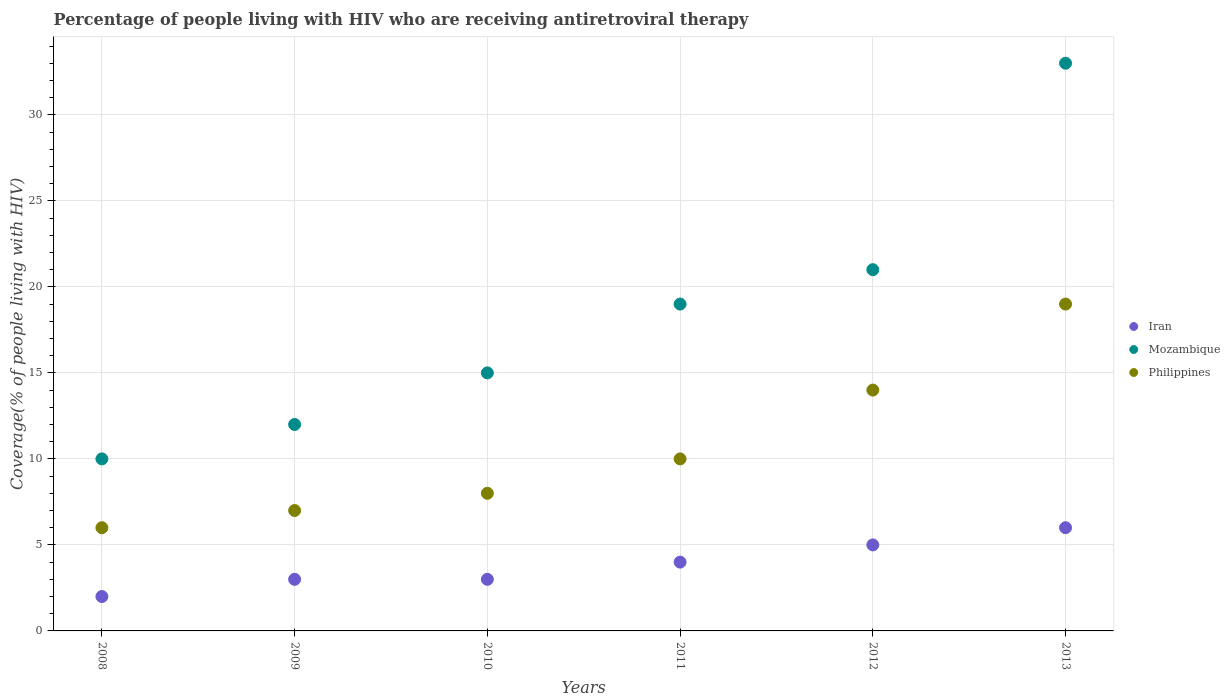Is the number of dotlines equal to the number of legend labels?
Your answer should be compact. Yes. What is the percentage of the HIV infected people who are receiving antiretroviral therapy in Mozambique in 2012?
Give a very brief answer. 21. Across all years, what is the maximum percentage of the HIV infected people who are receiving antiretroviral therapy in Iran?
Your answer should be very brief. 6. What is the total percentage of the HIV infected people who are receiving antiretroviral therapy in Philippines in the graph?
Give a very brief answer. 64. What is the difference between the percentage of the HIV infected people who are receiving antiretroviral therapy in Iran in 2010 and that in 2011?
Give a very brief answer. -1. What is the difference between the percentage of the HIV infected people who are receiving antiretroviral therapy in Mozambique in 2011 and the percentage of the HIV infected people who are receiving antiretroviral therapy in Iran in 2013?
Your response must be concise. 13. What is the average percentage of the HIV infected people who are receiving antiretroviral therapy in Mozambique per year?
Provide a short and direct response. 18.33. In the year 2008, what is the difference between the percentage of the HIV infected people who are receiving antiretroviral therapy in Iran and percentage of the HIV infected people who are receiving antiretroviral therapy in Mozambique?
Your response must be concise. -8. What is the ratio of the percentage of the HIV infected people who are receiving antiretroviral therapy in Iran in 2009 to that in 2012?
Your answer should be very brief. 0.6. Is the percentage of the HIV infected people who are receiving antiretroviral therapy in Mozambique in 2009 less than that in 2013?
Provide a short and direct response. Yes. Is the difference between the percentage of the HIV infected people who are receiving antiretroviral therapy in Iran in 2009 and 2012 greater than the difference between the percentage of the HIV infected people who are receiving antiretroviral therapy in Mozambique in 2009 and 2012?
Make the answer very short. Yes. What is the difference between the highest and the second highest percentage of the HIV infected people who are receiving antiretroviral therapy in Iran?
Your answer should be compact. 1. What is the difference between the highest and the lowest percentage of the HIV infected people who are receiving antiretroviral therapy in Philippines?
Your answer should be very brief. 13. Is the sum of the percentage of the HIV infected people who are receiving antiretroviral therapy in Iran in 2009 and 2013 greater than the maximum percentage of the HIV infected people who are receiving antiretroviral therapy in Mozambique across all years?
Make the answer very short. No. Is it the case that in every year, the sum of the percentage of the HIV infected people who are receiving antiretroviral therapy in Iran and percentage of the HIV infected people who are receiving antiretroviral therapy in Philippines  is greater than the percentage of the HIV infected people who are receiving antiretroviral therapy in Mozambique?
Your response must be concise. No. Is the percentage of the HIV infected people who are receiving antiretroviral therapy in Iran strictly less than the percentage of the HIV infected people who are receiving antiretroviral therapy in Mozambique over the years?
Offer a terse response. Yes. How many dotlines are there?
Offer a very short reply. 3. How many years are there in the graph?
Provide a short and direct response. 6. What is the difference between two consecutive major ticks on the Y-axis?
Your answer should be compact. 5. What is the title of the graph?
Your answer should be very brief. Percentage of people living with HIV who are receiving antiretroviral therapy. What is the label or title of the Y-axis?
Your answer should be very brief. Coverage(% of people living with HIV). What is the Coverage(% of people living with HIV) of Iran in 2008?
Offer a very short reply. 2. What is the Coverage(% of people living with HIV) in Philippines in 2009?
Give a very brief answer. 7. What is the Coverage(% of people living with HIV) of Iran in 2010?
Your response must be concise. 3. What is the Coverage(% of people living with HIV) of Iran in 2011?
Make the answer very short. 4. What is the Coverage(% of people living with HIV) of Mozambique in 2011?
Provide a succinct answer. 19. What is the Coverage(% of people living with HIV) in Iran in 2013?
Offer a very short reply. 6. What is the Coverage(% of people living with HIV) in Philippines in 2013?
Keep it short and to the point. 19. Across all years, what is the maximum Coverage(% of people living with HIV) in Iran?
Your answer should be very brief. 6. Across all years, what is the minimum Coverage(% of people living with HIV) in Iran?
Your response must be concise. 2. Across all years, what is the minimum Coverage(% of people living with HIV) in Mozambique?
Offer a terse response. 10. Across all years, what is the minimum Coverage(% of people living with HIV) of Philippines?
Your answer should be very brief. 6. What is the total Coverage(% of people living with HIV) in Mozambique in the graph?
Make the answer very short. 110. What is the total Coverage(% of people living with HIV) of Philippines in the graph?
Make the answer very short. 64. What is the difference between the Coverage(% of people living with HIV) in Iran in 2008 and that in 2009?
Give a very brief answer. -1. What is the difference between the Coverage(% of people living with HIV) in Mozambique in 2008 and that in 2009?
Ensure brevity in your answer.  -2. What is the difference between the Coverage(% of people living with HIV) of Philippines in 2008 and that in 2009?
Give a very brief answer. -1. What is the difference between the Coverage(% of people living with HIV) of Iran in 2008 and that in 2011?
Give a very brief answer. -2. What is the difference between the Coverage(% of people living with HIV) of Iran in 2008 and that in 2012?
Provide a succinct answer. -3. What is the difference between the Coverage(% of people living with HIV) of Iran in 2008 and that in 2013?
Offer a terse response. -4. What is the difference between the Coverage(% of people living with HIV) of Philippines in 2008 and that in 2013?
Your response must be concise. -13. What is the difference between the Coverage(% of people living with HIV) in Iran in 2009 and that in 2010?
Your response must be concise. 0. What is the difference between the Coverage(% of people living with HIV) of Philippines in 2009 and that in 2010?
Give a very brief answer. -1. What is the difference between the Coverage(% of people living with HIV) of Iran in 2009 and that in 2011?
Keep it short and to the point. -1. What is the difference between the Coverage(% of people living with HIV) of Philippines in 2009 and that in 2013?
Provide a succinct answer. -12. What is the difference between the Coverage(% of people living with HIV) of Mozambique in 2010 and that in 2011?
Make the answer very short. -4. What is the difference between the Coverage(% of people living with HIV) of Philippines in 2010 and that in 2011?
Your answer should be very brief. -2. What is the difference between the Coverage(% of people living with HIV) in Mozambique in 2010 and that in 2012?
Keep it short and to the point. -6. What is the difference between the Coverage(% of people living with HIV) in Philippines in 2010 and that in 2012?
Provide a short and direct response. -6. What is the difference between the Coverage(% of people living with HIV) of Mozambique in 2011 and that in 2012?
Make the answer very short. -2. What is the difference between the Coverage(% of people living with HIV) in Philippines in 2011 and that in 2012?
Your answer should be very brief. -4. What is the difference between the Coverage(% of people living with HIV) of Philippines in 2011 and that in 2013?
Make the answer very short. -9. What is the difference between the Coverage(% of people living with HIV) in Iran in 2012 and that in 2013?
Give a very brief answer. -1. What is the difference between the Coverage(% of people living with HIV) in Iran in 2008 and the Coverage(% of people living with HIV) in Mozambique in 2009?
Give a very brief answer. -10. What is the difference between the Coverage(% of people living with HIV) in Iran in 2008 and the Coverage(% of people living with HIV) in Philippines in 2009?
Offer a terse response. -5. What is the difference between the Coverage(% of people living with HIV) of Iran in 2008 and the Coverage(% of people living with HIV) of Mozambique in 2010?
Keep it short and to the point. -13. What is the difference between the Coverage(% of people living with HIV) of Iran in 2008 and the Coverage(% of people living with HIV) of Philippines in 2011?
Your answer should be very brief. -8. What is the difference between the Coverage(% of people living with HIV) in Mozambique in 2008 and the Coverage(% of people living with HIV) in Philippines in 2011?
Provide a succinct answer. 0. What is the difference between the Coverage(% of people living with HIV) in Iran in 2008 and the Coverage(% of people living with HIV) in Mozambique in 2013?
Give a very brief answer. -31. What is the difference between the Coverage(% of people living with HIV) of Iran in 2008 and the Coverage(% of people living with HIV) of Philippines in 2013?
Your answer should be compact. -17. What is the difference between the Coverage(% of people living with HIV) in Iran in 2009 and the Coverage(% of people living with HIV) in Philippines in 2010?
Ensure brevity in your answer.  -5. What is the difference between the Coverage(% of people living with HIV) in Mozambique in 2009 and the Coverage(% of people living with HIV) in Philippines in 2010?
Provide a short and direct response. 4. What is the difference between the Coverage(% of people living with HIV) of Mozambique in 2009 and the Coverage(% of people living with HIV) of Philippines in 2011?
Your answer should be very brief. 2. What is the difference between the Coverage(% of people living with HIV) in Iran in 2009 and the Coverage(% of people living with HIV) in Philippines in 2012?
Provide a short and direct response. -11. What is the difference between the Coverage(% of people living with HIV) of Mozambique in 2009 and the Coverage(% of people living with HIV) of Philippines in 2012?
Give a very brief answer. -2. What is the difference between the Coverage(% of people living with HIV) in Iran in 2009 and the Coverage(% of people living with HIV) in Mozambique in 2013?
Offer a very short reply. -30. What is the difference between the Coverage(% of people living with HIV) of Mozambique in 2009 and the Coverage(% of people living with HIV) of Philippines in 2013?
Keep it short and to the point. -7. What is the difference between the Coverage(% of people living with HIV) in Iran in 2010 and the Coverage(% of people living with HIV) in Mozambique in 2011?
Give a very brief answer. -16. What is the difference between the Coverage(% of people living with HIV) of Iran in 2010 and the Coverage(% of people living with HIV) of Mozambique in 2012?
Make the answer very short. -18. What is the difference between the Coverage(% of people living with HIV) in Iran in 2010 and the Coverage(% of people living with HIV) in Philippines in 2012?
Make the answer very short. -11. What is the difference between the Coverage(% of people living with HIV) of Iran in 2010 and the Coverage(% of people living with HIV) of Philippines in 2013?
Make the answer very short. -16. What is the difference between the Coverage(% of people living with HIV) in Iran in 2011 and the Coverage(% of people living with HIV) in Mozambique in 2012?
Offer a terse response. -17. What is the difference between the Coverage(% of people living with HIV) in Iran in 2011 and the Coverage(% of people living with HIV) in Mozambique in 2013?
Give a very brief answer. -29. What is the difference between the Coverage(% of people living with HIV) of Mozambique in 2011 and the Coverage(% of people living with HIV) of Philippines in 2013?
Provide a short and direct response. 0. What is the difference between the Coverage(% of people living with HIV) in Iran in 2012 and the Coverage(% of people living with HIV) in Mozambique in 2013?
Offer a terse response. -28. What is the difference between the Coverage(% of people living with HIV) in Mozambique in 2012 and the Coverage(% of people living with HIV) in Philippines in 2013?
Ensure brevity in your answer.  2. What is the average Coverage(% of people living with HIV) in Iran per year?
Offer a terse response. 3.83. What is the average Coverage(% of people living with HIV) of Mozambique per year?
Offer a terse response. 18.33. What is the average Coverage(% of people living with HIV) of Philippines per year?
Offer a very short reply. 10.67. In the year 2008, what is the difference between the Coverage(% of people living with HIV) of Iran and Coverage(% of people living with HIV) of Philippines?
Offer a very short reply. -4. In the year 2010, what is the difference between the Coverage(% of people living with HIV) in Iran and Coverage(% of people living with HIV) in Philippines?
Offer a very short reply. -5. In the year 2011, what is the difference between the Coverage(% of people living with HIV) of Iran and Coverage(% of people living with HIV) of Mozambique?
Your answer should be compact. -15. In the year 2011, what is the difference between the Coverage(% of people living with HIV) in Mozambique and Coverage(% of people living with HIV) in Philippines?
Your answer should be very brief. 9. In the year 2012, what is the difference between the Coverage(% of people living with HIV) of Iran and Coverage(% of people living with HIV) of Mozambique?
Make the answer very short. -16. In the year 2012, what is the difference between the Coverage(% of people living with HIV) in Iran and Coverage(% of people living with HIV) in Philippines?
Offer a terse response. -9. In the year 2012, what is the difference between the Coverage(% of people living with HIV) in Mozambique and Coverage(% of people living with HIV) in Philippines?
Your answer should be compact. 7. In the year 2013, what is the difference between the Coverage(% of people living with HIV) in Iran and Coverage(% of people living with HIV) in Mozambique?
Keep it short and to the point. -27. What is the ratio of the Coverage(% of people living with HIV) of Iran in 2008 to that in 2009?
Provide a short and direct response. 0.67. What is the ratio of the Coverage(% of people living with HIV) of Mozambique in 2008 to that in 2009?
Ensure brevity in your answer.  0.83. What is the ratio of the Coverage(% of people living with HIV) in Philippines in 2008 to that in 2009?
Provide a short and direct response. 0.86. What is the ratio of the Coverage(% of people living with HIV) of Iran in 2008 to that in 2010?
Your answer should be very brief. 0.67. What is the ratio of the Coverage(% of people living with HIV) in Philippines in 2008 to that in 2010?
Provide a short and direct response. 0.75. What is the ratio of the Coverage(% of people living with HIV) in Iran in 2008 to that in 2011?
Provide a succinct answer. 0.5. What is the ratio of the Coverage(% of people living with HIV) in Mozambique in 2008 to that in 2011?
Keep it short and to the point. 0.53. What is the ratio of the Coverage(% of people living with HIV) of Iran in 2008 to that in 2012?
Offer a very short reply. 0.4. What is the ratio of the Coverage(% of people living with HIV) in Mozambique in 2008 to that in 2012?
Your answer should be compact. 0.48. What is the ratio of the Coverage(% of people living with HIV) of Philippines in 2008 to that in 2012?
Give a very brief answer. 0.43. What is the ratio of the Coverage(% of people living with HIV) in Mozambique in 2008 to that in 2013?
Your answer should be very brief. 0.3. What is the ratio of the Coverage(% of people living with HIV) of Philippines in 2008 to that in 2013?
Your answer should be compact. 0.32. What is the ratio of the Coverage(% of people living with HIV) in Philippines in 2009 to that in 2010?
Offer a very short reply. 0.88. What is the ratio of the Coverage(% of people living with HIV) of Iran in 2009 to that in 2011?
Your response must be concise. 0.75. What is the ratio of the Coverage(% of people living with HIV) in Mozambique in 2009 to that in 2011?
Offer a very short reply. 0.63. What is the ratio of the Coverage(% of people living with HIV) in Mozambique in 2009 to that in 2013?
Keep it short and to the point. 0.36. What is the ratio of the Coverage(% of people living with HIV) of Philippines in 2009 to that in 2013?
Ensure brevity in your answer.  0.37. What is the ratio of the Coverage(% of people living with HIV) in Iran in 2010 to that in 2011?
Make the answer very short. 0.75. What is the ratio of the Coverage(% of people living with HIV) in Mozambique in 2010 to that in 2011?
Provide a short and direct response. 0.79. What is the ratio of the Coverage(% of people living with HIV) of Iran in 2010 to that in 2012?
Give a very brief answer. 0.6. What is the ratio of the Coverage(% of people living with HIV) of Mozambique in 2010 to that in 2013?
Your response must be concise. 0.45. What is the ratio of the Coverage(% of people living with HIV) of Philippines in 2010 to that in 2013?
Your answer should be very brief. 0.42. What is the ratio of the Coverage(% of people living with HIV) of Mozambique in 2011 to that in 2012?
Your answer should be very brief. 0.9. What is the ratio of the Coverage(% of people living with HIV) of Mozambique in 2011 to that in 2013?
Make the answer very short. 0.58. What is the ratio of the Coverage(% of people living with HIV) in Philippines in 2011 to that in 2013?
Keep it short and to the point. 0.53. What is the ratio of the Coverage(% of people living with HIV) in Mozambique in 2012 to that in 2013?
Ensure brevity in your answer.  0.64. What is the ratio of the Coverage(% of people living with HIV) of Philippines in 2012 to that in 2013?
Offer a very short reply. 0.74. What is the difference between the highest and the lowest Coverage(% of people living with HIV) in Iran?
Your answer should be compact. 4. What is the difference between the highest and the lowest Coverage(% of people living with HIV) of Philippines?
Your response must be concise. 13. 